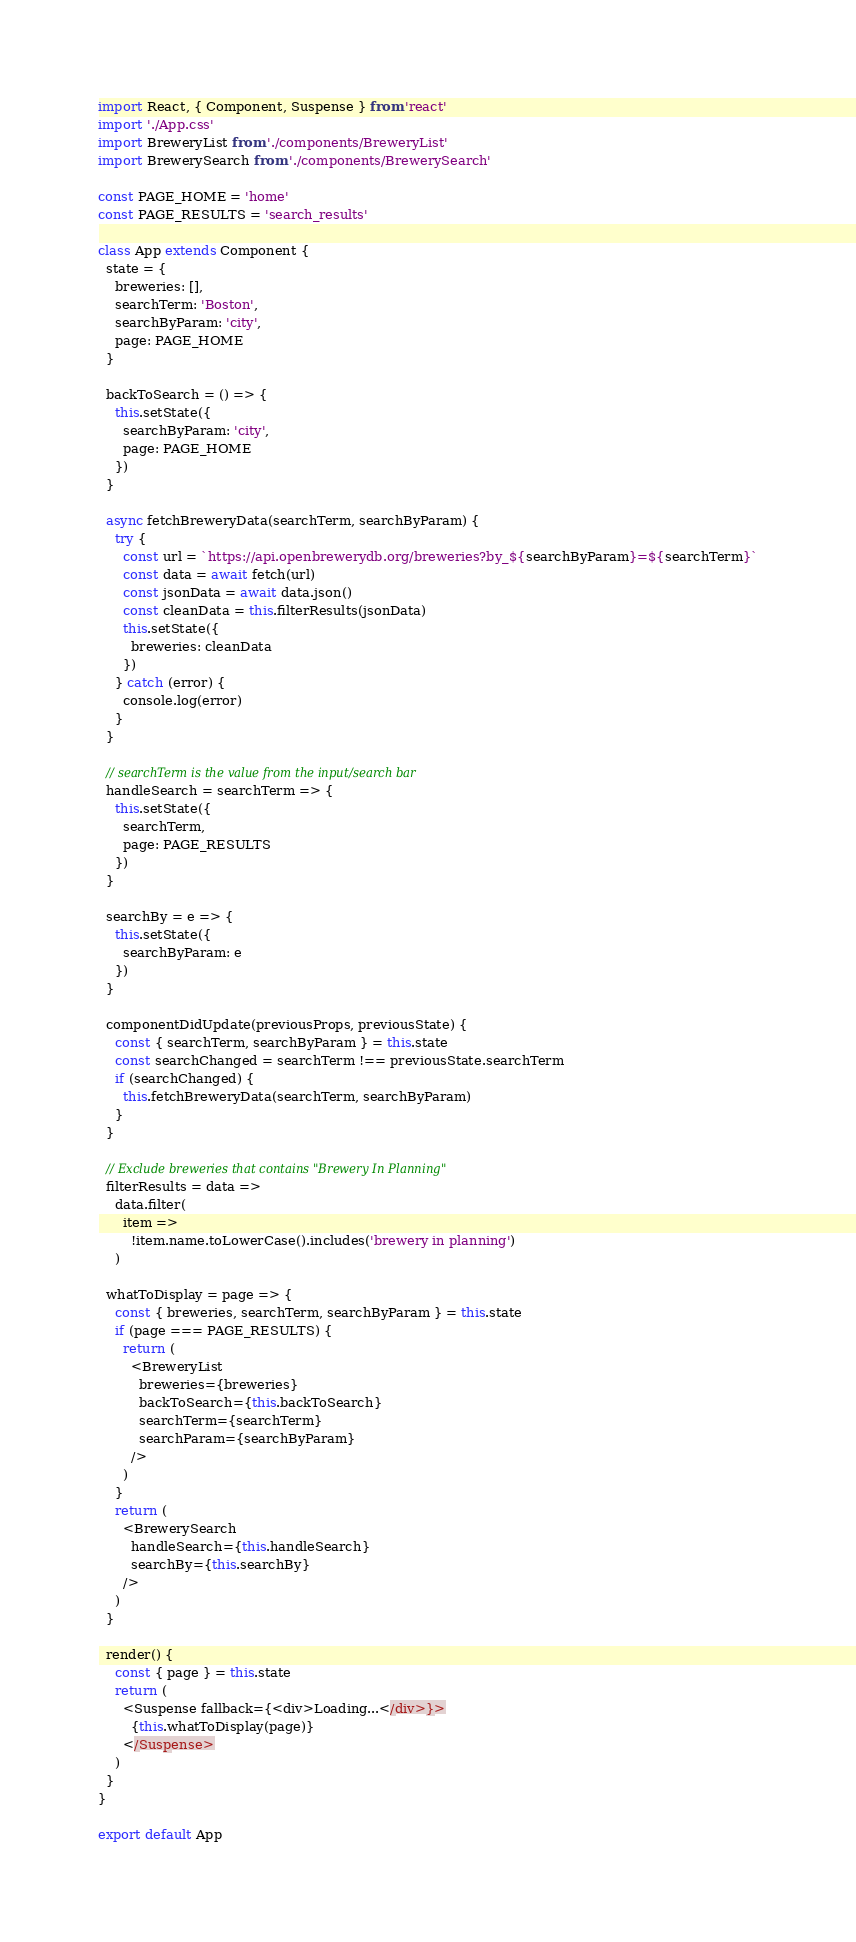Convert code to text. <code><loc_0><loc_0><loc_500><loc_500><_JavaScript_>import React, { Component, Suspense } from 'react'
import './App.css'
import BreweryList from './components/BreweryList'
import BrewerySearch from './components/BrewerySearch'

const PAGE_HOME = 'home'
const PAGE_RESULTS = 'search_results'

class App extends Component {
  state = {
    breweries: [],
    searchTerm: 'Boston',
    searchByParam: 'city',
    page: PAGE_HOME
  }

  backToSearch = () => {
    this.setState({
      searchByParam: 'city',
      page: PAGE_HOME
    })
  }

  async fetchBreweryData(searchTerm, searchByParam) {
    try {
      const url = `https://api.openbrewerydb.org/breweries?by_${searchByParam}=${searchTerm}`
      const data = await fetch(url)
      const jsonData = await data.json()
      const cleanData = this.filterResults(jsonData)
      this.setState({
        breweries: cleanData
      })
    } catch (error) {
      console.log(error)
    }
  }

  // searchTerm is the value from the input/search bar
  handleSearch = searchTerm => {
    this.setState({
      searchTerm,
      page: PAGE_RESULTS
    })
  }

  searchBy = e => {
    this.setState({
      searchByParam: e
    })
  }

  componentDidUpdate(previousProps, previousState) {
    const { searchTerm, searchByParam } = this.state
    const searchChanged = searchTerm !== previousState.searchTerm
    if (searchChanged) {
      this.fetchBreweryData(searchTerm, searchByParam)
    }
  }

  // Exclude breweries that contains "Brewery In Planning"
  filterResults = data =>
    data.filter(
      item =>
        !item.name.toLowerCase().includes('brewery in planning')
    )

  whatToDisplay = page => {
    const { breweries, searchTerm, searchByParam } = this.state
    if (page === PAGE_RESULTS) {
      return (
        <BreweryList
          breweries={breweries}
          backToSearch={this.backToSearch}
          searchTerm={searchTerm}
          searchParam={searchByParam}
        />
      )
    }
    return (
      <BrewerySearch
        handleSearch={this.handleSearch}
        searchBy={this.searchBy}
      />
    )
  }

  render() {
    const { page } = this.state
    return (
      <Suspense fallback={<div>Loading...</div>}>
        {this.whatToDisplay(page)}
      </Suspense>
    )
  }
}

export default App
</code> 